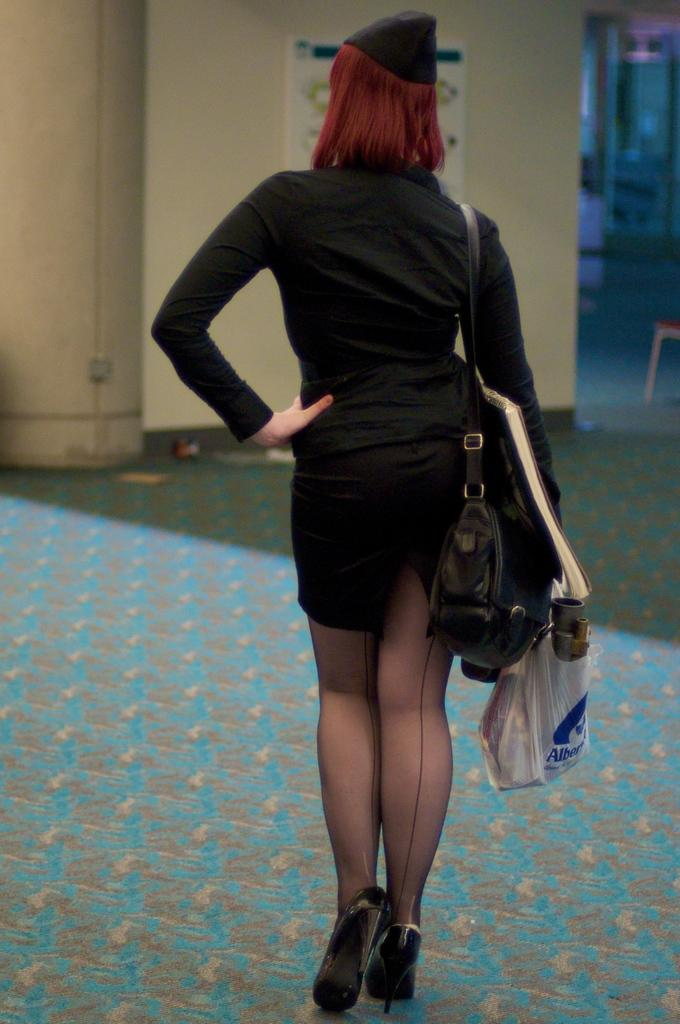Who is present in the image? There is a woman in the image. What is the woman wearing? The woman is wearing a bag. What is the woman holding in her hands? The woman is holding a book and a plastic bag. What can be seen on the wall in the image? There is a board on the wall in the image. What type of voice can be heard coming from the woman in the image? There is no indication of any voice or sound in the image, so it cannot be determined. 